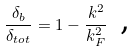Convert formula to latex. <formula><loc_0><loc_0><loc_500><loc_500>\frac { \delta _ { b } } { \delta _ { t o t } } = 1 - \frac { k ^ { 2 } } { k _ { F } ^ { 2 } } \, \text { ,}</formula> 